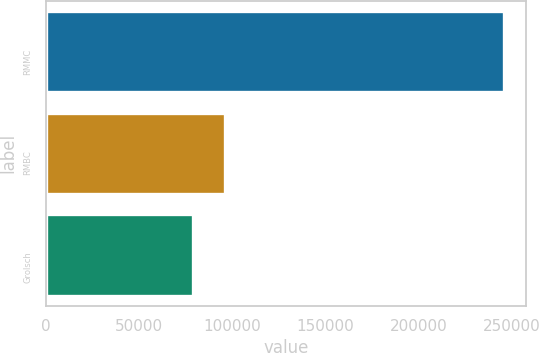Convert chart to OTSL. <chart><loc_0><loc_0><loc_500><loc_500><bar_chart><fcel>RMMC<fcel>RMBC<fcel>Grolsch<nl><fcel>245371<fcel>96009<fcel>79007<nl></chart> 